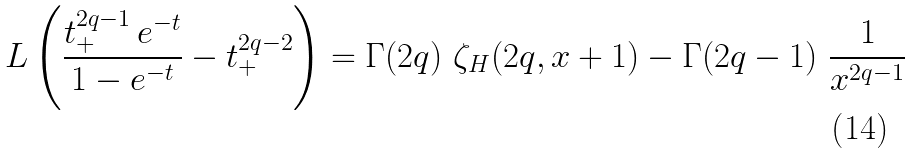<formula> <loc_0><loc_0><loc_500><loc_500>\L L \left ( \frac { t _ { + } ^ { 2 q - 1 } \, e ^ { - t } } { 1 - e ^ { - t } } - t _ { + } ^ { 2 q - 2 } \right ) = \Gamma ( 2 q ) \ \zeta _ { H } ( 2 q , x + 1 ) - \Gamma ( 2 q - 1 ) \ \frac { 1 } { x ^ { 2 q - 1 } }</formula> 